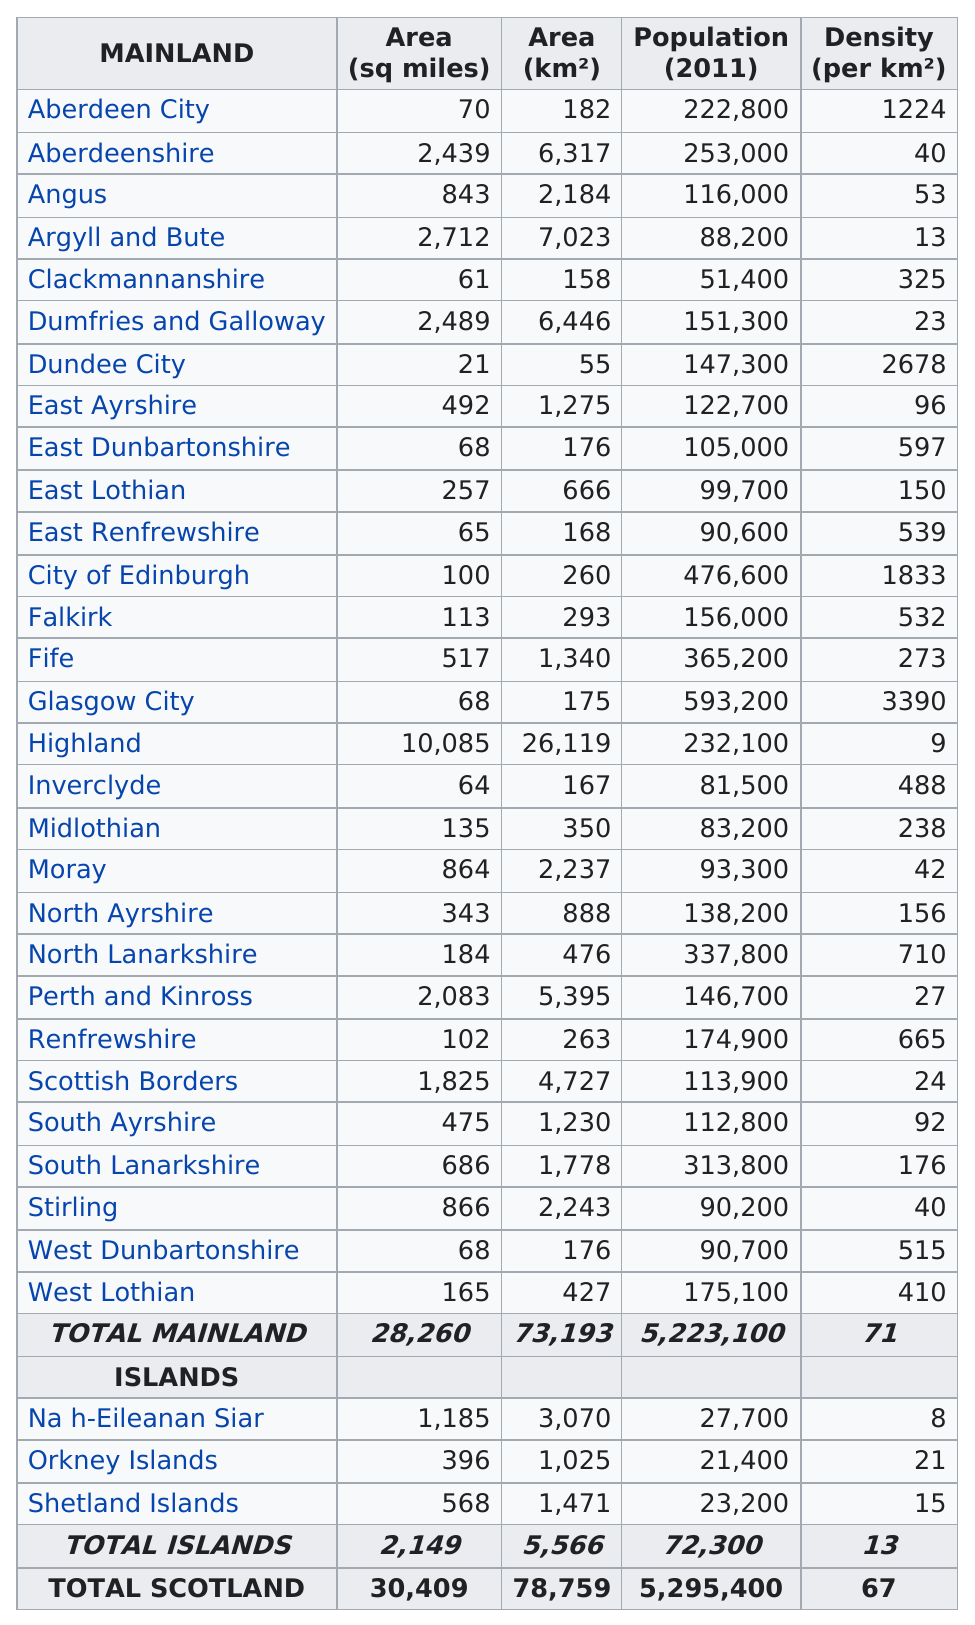Specify some key components in this picture. The total area of East Lothian, Angus, and Dundee City is 1121. The difference in square miles between Angus and Fife is 326. In the year 2011, there were 116,000 individuals residing in the region of Angus. Dundee City would be the first location in the list if the locations were arranged from smallest to largest area. What mainland has the lowest density? It's the Highlands. 